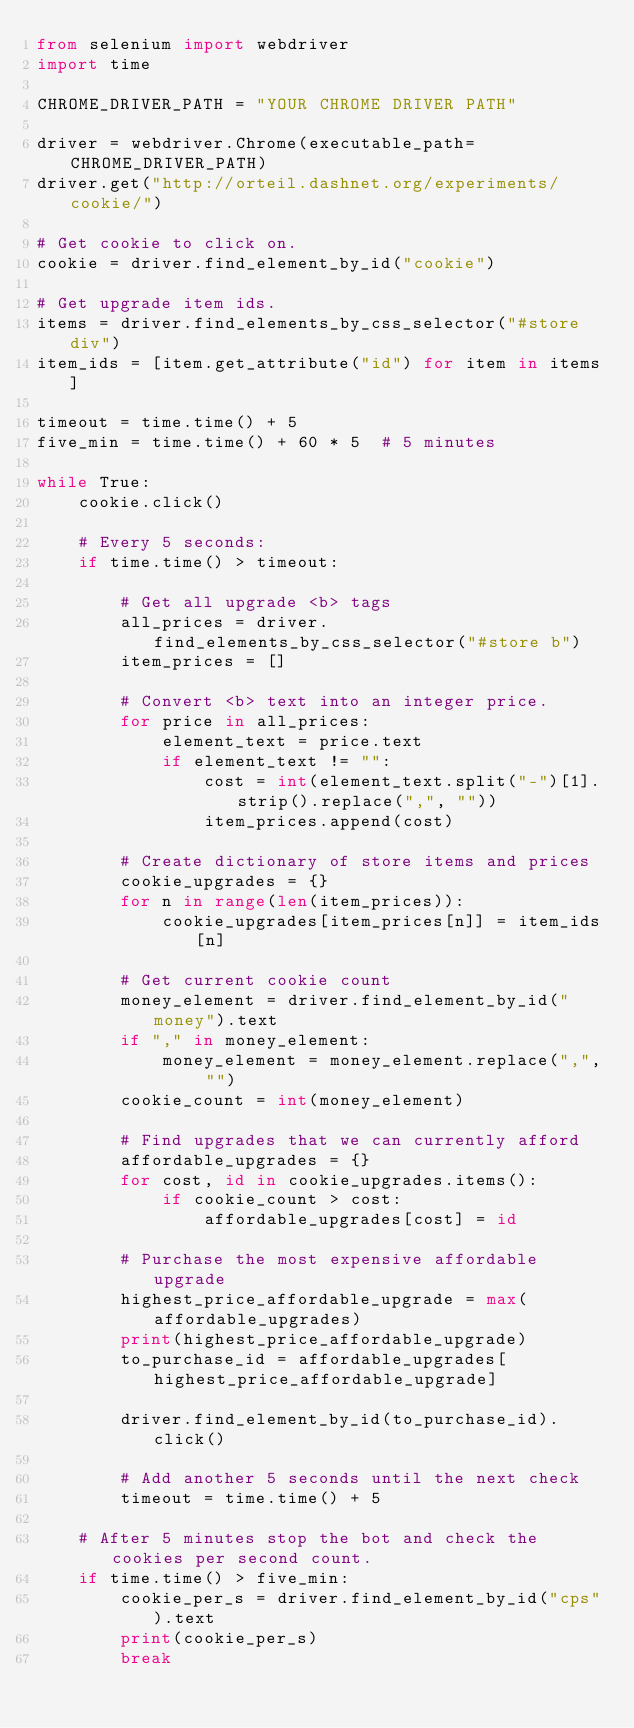<code> <loc_0><loc_0><loc_500><loc_500><_Python_>from selenium import webdriver
import time

CHROME_DRIVER_PATH = "YOUR CHROME DRIVER PATH"

driver = webdriver.Chrome(executable_path=CHROME_DRIVER_PATH)
driver.get("http://orteil.dashnet.org/experiments/cookie/")

# Get cookie to click on.
cookie = driver.find_element_by_id("cookie")

# Get upgrade item ids.
items = driver.find_elements_by_css_selector("#store div")
item_ids = [item.get_attribute("id") for item in items]

timeout = time.time() + 5
five_min = time.time() + 60 * 5  # 5 minutes

while True:
    cookie.click()

    # Every 5 seconds:
    if time.time() > timeout:

        # Get all upgrade <b> tags
        all_prices = driver.find_elements_by_css_selector("#store b")
        item_prices = []

        # Convert <b> text into an integer price.
        for price in all_prices:
            element_text = price.text
            if element_text != "":
                cost = int(element_text.split("-")[1].strip().replace(",", ""))
                item_prices.append(cost)

        # Create dictionary of store items and prices
        cookie_upgrades = {}
        for n in range(len(item_prices)):
            cookie_upgrades[item_prices[n]] = item_ids[n]

        # Get current cookie count
        money_element = driver.find_element_by_id("money").text
        if "," in money_element:
            money_element = money_element.replace(",", "")
        cookie_count = int(money_element)

        # Find upgrades that we can currently afford
        affordable_upgrades = {}
        for cost, id in cookie_upgrades.items():
            if cookie_count > cost:
                affordable_upgrades[cost] = id

        # Purchase the most expensive affordable upgrade
        highest_price_affordable_upgrade = max(affordable_upgrades)
        print(highest_price_affordable_upgrade)
        to_purchase_id = affordable_upgrades[highest_price_affordable_upgrade]

        driver.find_element_by_id(to_purchase_id).click()

        # Add another 5 seconds until the next check
        timeout = time.time() + 5

    # After 5 minutes stop the bot and check the cookies per second count.
    if time.time() > five_min:
        cookie_per_s = driver.find_element_by_id("cps").text
        print(cookie_per_s)
        break
</code> 